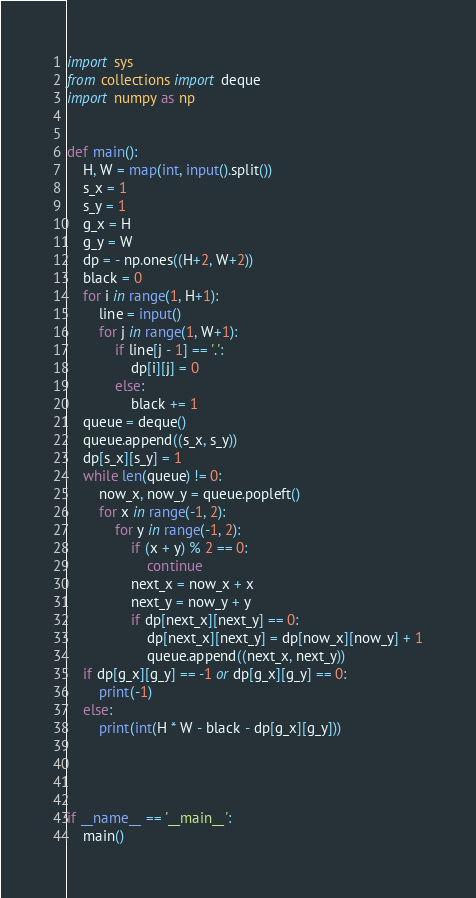Convert code to text. <code><loc_0><loc_0><loc_500><loc_500><_Python_>import sys
from collections import deque
import numpy as np


def main():
    H, W = map(int, input().split())
    s_x = 1
    s_y = 1
    g_x = H
    g_y = W
    dp = - np.ones((H+2, W+2))
    black = 0
    for i in range(1, H+1):
        line = input()
        for j in range(1, W+1):
            if line[j - 1] == '.':
                dp[i][j] = 0
            else:
                black += 1
    queue = deque()
    queue.append((s_x, s_y))
    dp[s_x][s_y] = 1
    while len(queue) != 0:
        now_x, now_y = queue.popleft()
        for x in range(-1, 2):
            for y in range(-1, 2):
                if (x + y) % 2 == 0:
                    continue
                next_x = now_x + x
                next_y = now_y + y
                if dp[next_x][next_y] == 0:
                    dp[next_x][next_y] = dp[now_x][now_y] + 1
                    queue.append((next_x, next_y))
    if dp[g_x][g_y] == -1 or dp[g_x][g_y] == 0:
        print(-1)
    else:
        print(int(H * W - black - dp[g_x][g_y]))




if __name__ == '__main__':
    main()
</code> 